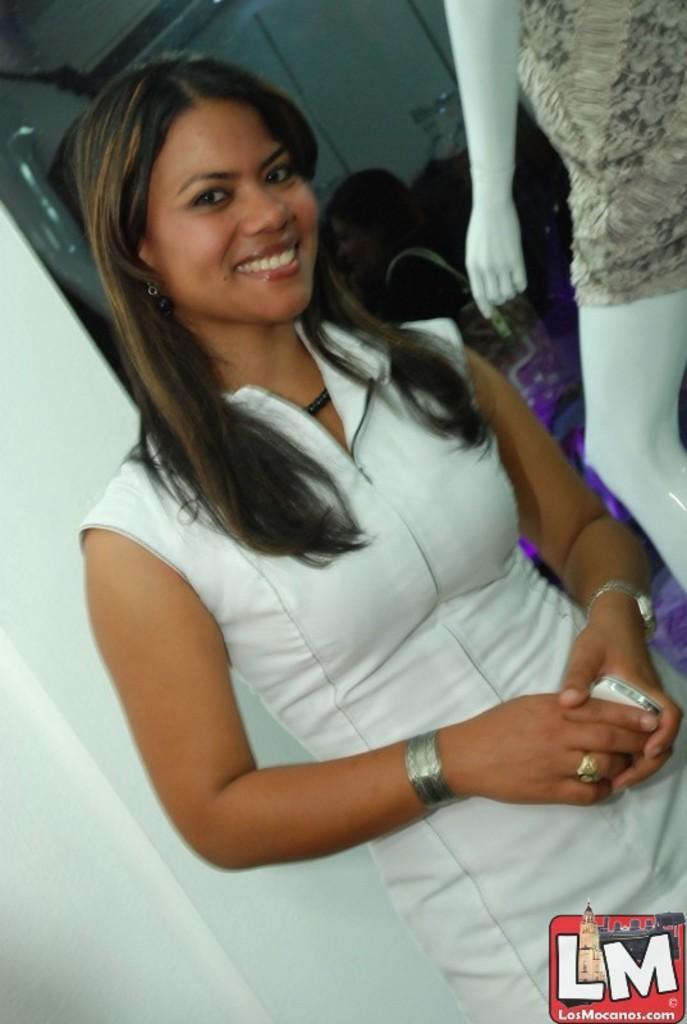Could you give a brief overview of what you see in this image? In this picture there is a girl in the center of the image and there are other people and a statue in the background area of the image. 